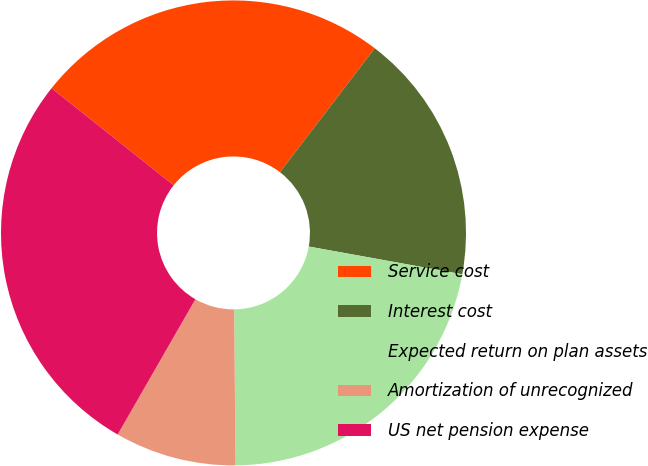Convert chart to OTSL. <chart><loc_0><loc_0><loc_500><loc_500><pie_chart><fcel>Service cost<fcel>Interest cost<fcel>Expected return on plan assets<fcel>Amortization of unrecognized<fcel>US net pension expense<nl><fcel>24.7%<fcel>17.45%<fcel>22.01%<fcel>8.44%<fcel>27.39%<nl></chart> 